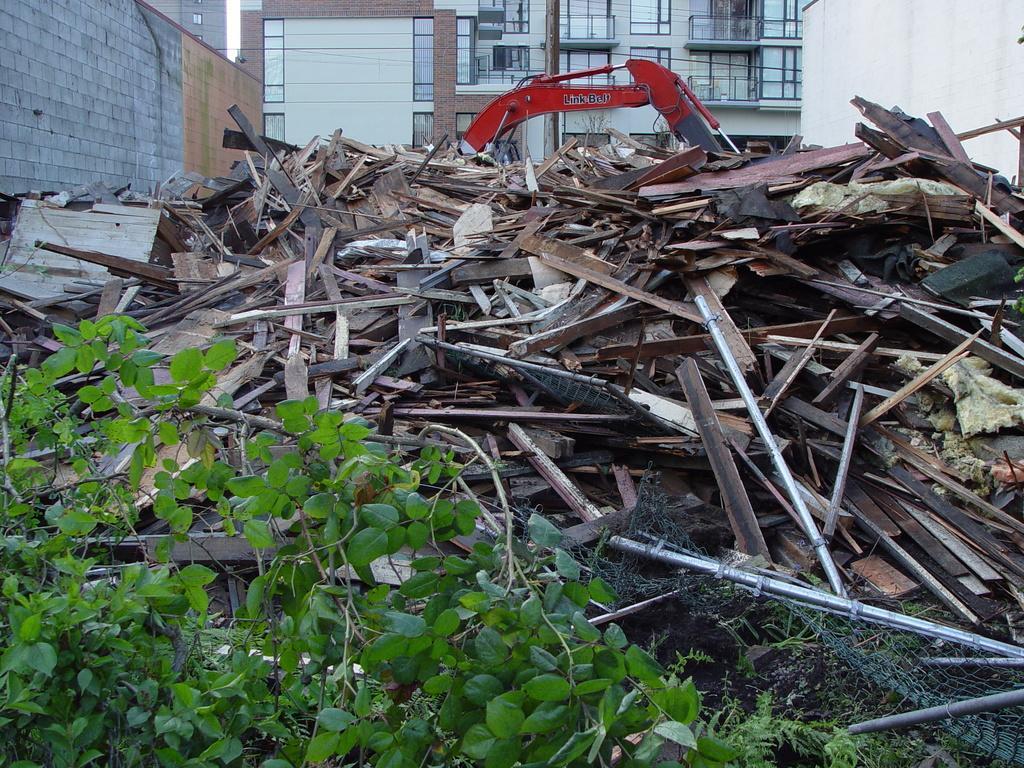How would you summarize this image in a sentence or two? Building with windows. Here we can see wooden sticks, vehicle, mesh, pole and plant. 